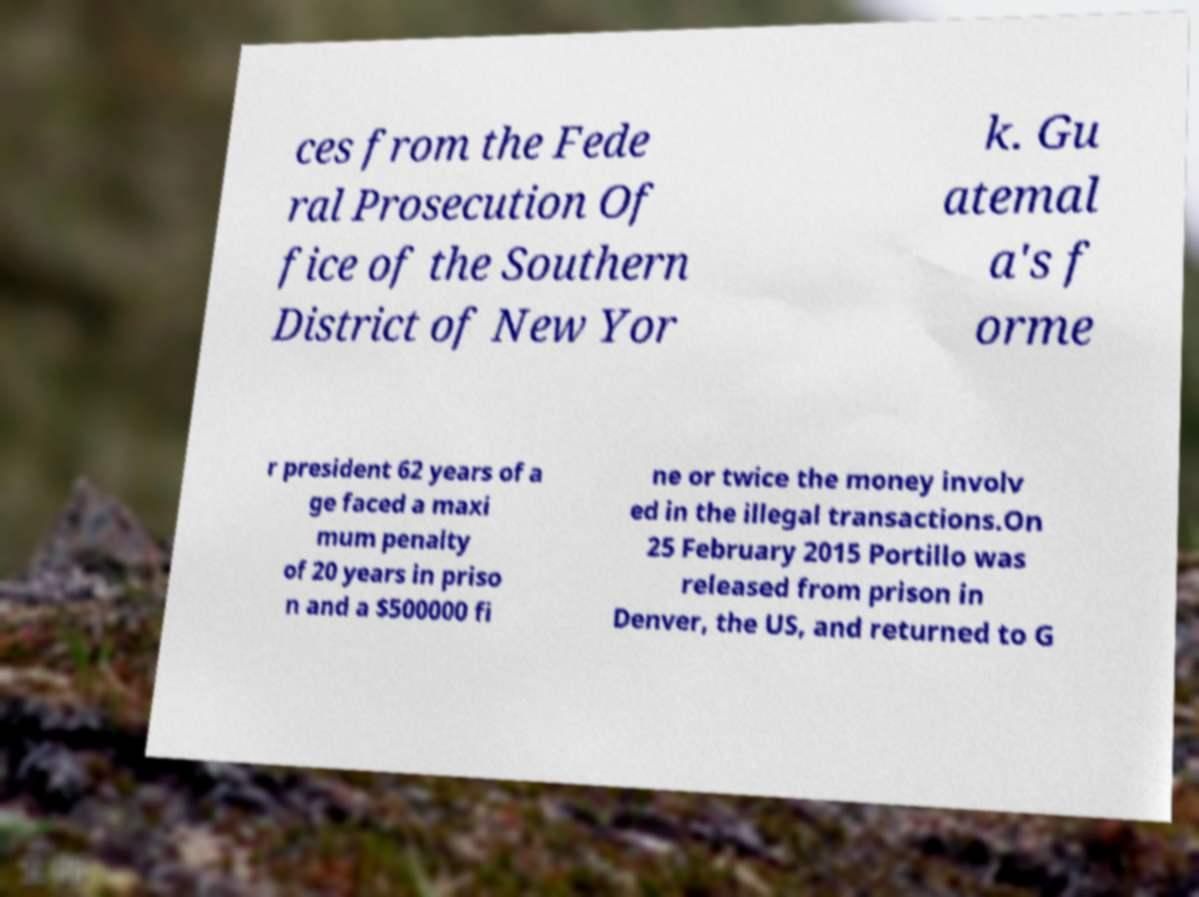Could you extract and type out the text from this image? ces from the Fede ral Prosecution Of fice of the Southern District of New Yor k. Gu atemal a's f orme r president 62 years of a ge faced a maxi mum penalty of 20 years in priso n and a $500000 fi ne or twice the money involv ed in the illegal transactions.On 25 February 2015 Portillo was released from prison in Denver, the US, and returned to G 